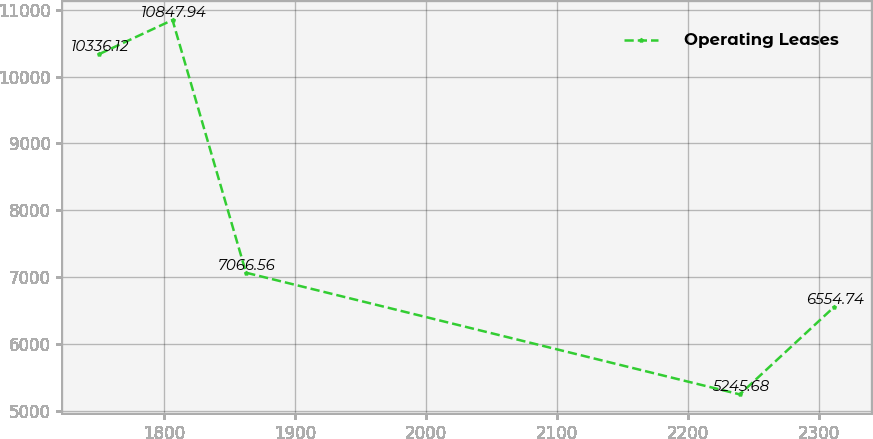<chart> <loc_0><loc_0><loc_500><loc_500><line_chart><ecel><fcel>Operating Leases<nl><fcel>1750.62<fcel>10336.1<nl><fcel>1806.71<fcel>10847.9<nl><fcel>1862.8<fcel>7066.56<nl><fcel>2239.55<fcel>5245.68<nl><fcel>2311.55<fcel>6554.74<nl></chart> 